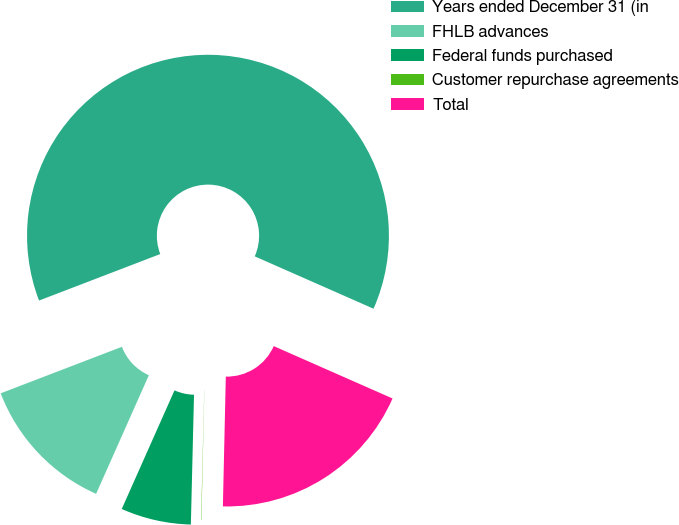<chart> <loc_0><loc_0><loc_500><loc_500><pie_chart><fcel>Years ended December 31 (in<fcel>FHLB advances<fcel>Federal funds purchased<fcel>Customer repurchase agreements<fcel>Total<nl><fcel>62.43%<fcel>12.51%<fcel>6.27%<fcel>0.03%<fcel>18.75%<nl></chart> 